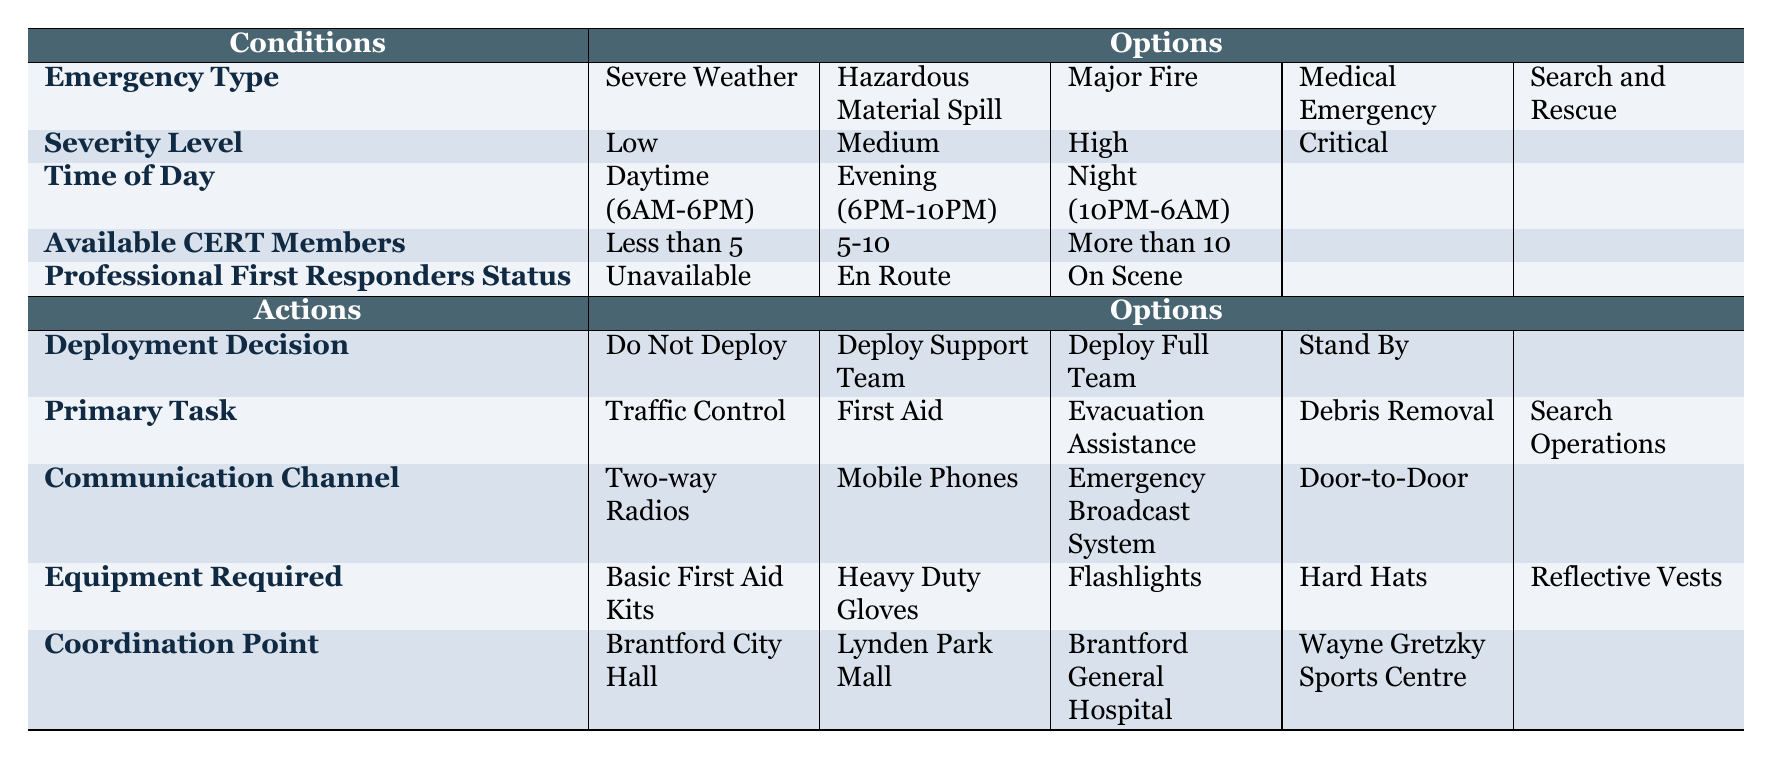What is the emergency type associated with a hazardous material spill? According to the table, "Hazardous Material Spill" is listed under the "Emergency Type" condition, which simply refers to the situation being addressed.
Answer: Hazardous Material Spill If available CERT members are less than 5, what should the deployment decision be? The table includes a row for "Deployment Decision" that indicates if available CERT members are less than 5, the recommendation is "Do Not Deploy."
Answer: Do Not Deploy Are professional first responders currently on scene for a major fire? The "Professional First Responders Status" must indicate "On Scene" for the major fire. However, since there is no direct entry regarding "Major Fire" in the rows, it's impossible to confirm. Therefore, the statement is false.
Answer: False What is the primary task when the emergency type is severe weather, and the severity level is critical? To determine the primary task, you need to cross-reference both the emergency type "Severe Weather" with its matching severity level of "Critical." If it matches an action for critical severity related to severe weather, you would identify that as the task. In the table, there are no specific primary tasks given, but it is common to expect tasks related to evacuation assistance or safety measures.
Answer: The answer is unspecified If there are more than 10 available CERT members at nighttime, which communication channel is recommended? The table does not specify communication channels by time of day or available members. Therefore, while it lists "Mobile Phones, Two-way Radios, Emergency Broadcast System, Door-to-Door," it does not direct which to utilize for more than 10 members at night. Thus, the answer remains uncertain.
Answer: The answer is unspecified How many options are available for the coordination point? The table specifies four coordination points under the "Coordination Point" action: "Brantford City Hall," "Lynden Park Mall," "Brantford General Hospital," and "Wayne Gretzky Sports Centre." Thus, by counting these entries, we find there are four options.
Answer: 4 For a critical medical emergency with available CERT members between 5-10, what is the recommended deployment decision? The table does not explicitly show all interactions between specific emergencies and their deployment decisions. To find the answer, one would check the severity level and CERT member count to find matching recommendations, likely resulting in "Deploy Support Team" for this combination.
Answer: Deploy Support Team What equipment is needed for evacuation assistance? Since the table does not directly link equipment required to specific tasks like "Evacuation Assistance," one would refer to commonly needed items like "Basic First Aid Kits" or "Reflective Vests." However, without explicit context, it cannot be definitively answered from the table.
Answer: The answer is unspecified 